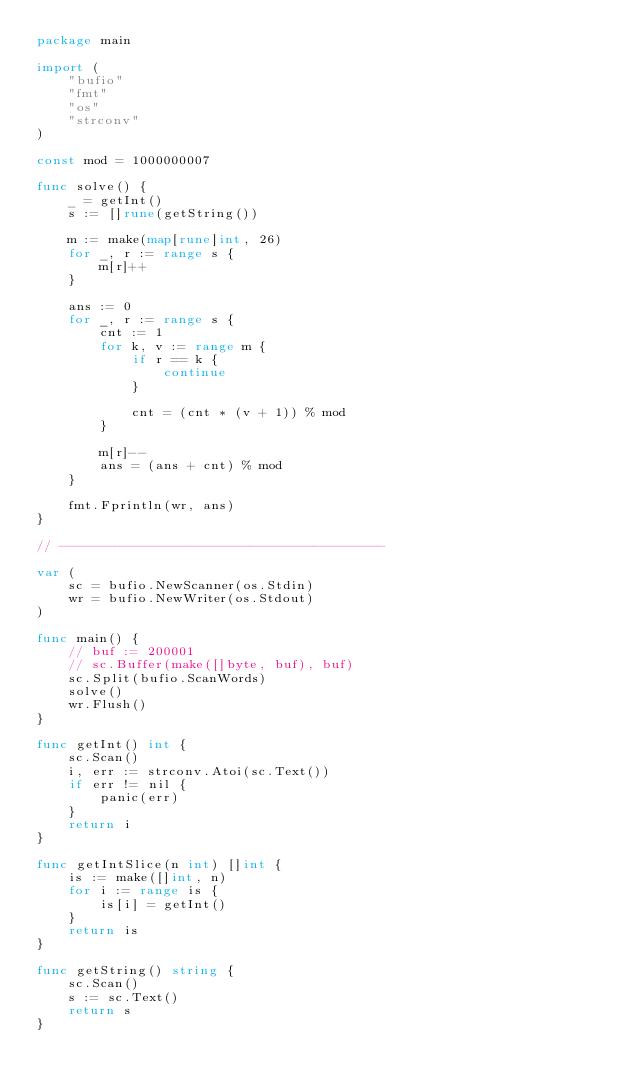<code> <loc_0><loc_0><loc_500><loc_500><_Go_>package main

import (
	"bufio"
	"fmt"
	"os"
	"strconv"
)

const mod = 1000000007

func solve() {
	_ = getInt()
	s := []rune(getString())

	m := make(map[rune]int, 26)
	for _, r := range s {
		m[r]++
	}

	ans := 0
	for _, r := range s {
		cnt := 1
		for k, v := range m {
			if r == k {
				continue
			}

			cnt = (cnt * (v + 1)) % mod
		}

		m[r]--
		ans = (ans + cnt) % mod
	}

	fmt.Fprintln(wr, ans)
}

// -----------------------------------------

var (
	sc = bufio.NewScanner(os.Stdin)
	wr = bufio.NewWriter(os.Stdout)
)

func main() {
	// buf := 200001
	// sc.Buffer(make([]byte, buf), buf)
	sc.Split(bufio.ScanWords)
	solve()
	wr.Flush()
}

func getInt() int {
	sc.Scan()
	i, err := strconv.Atoi(sc.Text())
	if err != nil {
		panic(err)
	}
	return i
}

func getIntSlice(n int) []int {
	is := make([]int, n)
	for i := range is {
		is[i] = getInt()
	}
	return is
}

func getString() string {
	sc.Scan()
	s := sc.Text()
	return s
}
</code> 